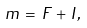Convert formula to latex. <formula><loc_0><loc_0><loc_500><loc_500>m \, = \, F \, + \, I ,</formula> 